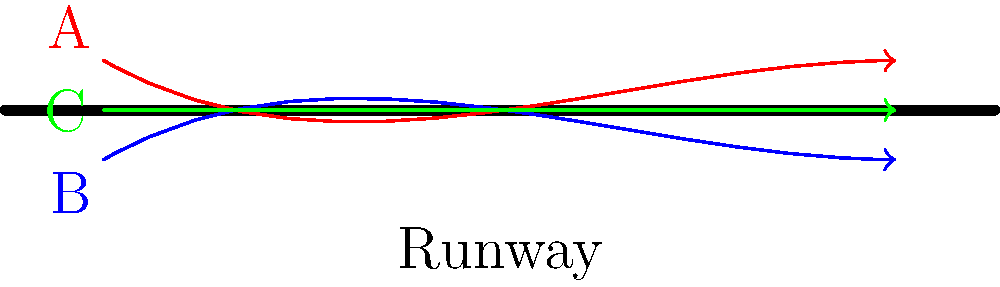In this fabulous runway show, three models (A, B, and C) strut their stuff with unique walk patterns. Which two walk patterns, if superimposed, would create congruent shapes on the catwalk? Let's break this down step-by-step with a touch of runway flair:

1. Model A (red path): Starts slightly above the runway line, curves downward, then straightens out. This creates a subtle S-shape.

2. Model B (blue path): Begins below the runway line, curves upward, then straightens out. This also forms an S-shape, but it's a mirror image of A's path.

3. Model C (green path): Walks straight down the center of the runway. No curves, just pure confidence!

4. To determine congruence, we need to consider shape and size, not position or orientation.

5. Comparing the paths:
   - A and B: These paths are mirror images of each other. If we flipped one over, they would overlap perfectly. In geometry, this means they're congruent.
   - A and C: One is curved, one is straight. Not congruent.
   - B and C: Again, one curved, one straight. Not congruent.

6. The key here is that congruent shapes can be transformed into each other through rigid motions (reflection, rotation, translation) without changing their size or shape.

Therefore, the walk patterns of models A and B would create congruent shapes if superimposed, just like two perfectly matched stilettos!
Answer: A and B 